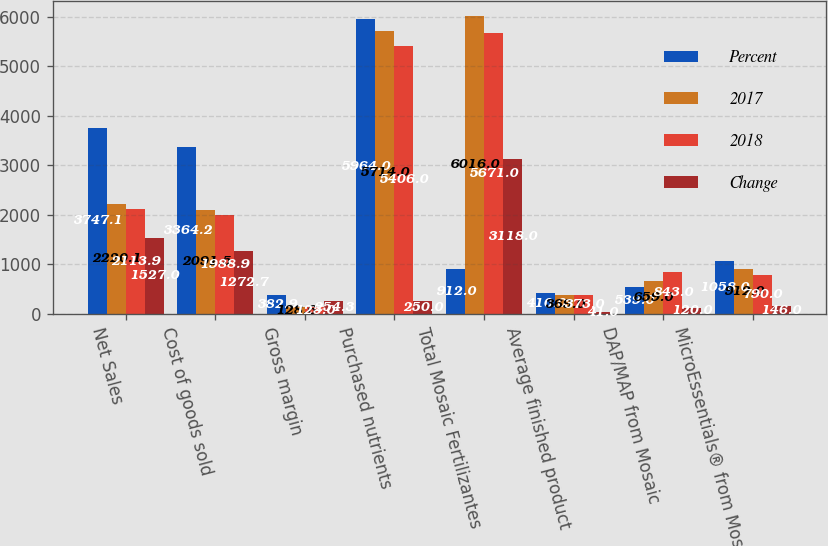Convert chart. <chart><loc_0><loc_0><loc_500><loc_500><stacked_bar_chart><ecel><fcel>Net Sales<fcel>Cost of goods sold<fcel>Gross margin<fcel>Purchased nutrients<fcel>Total Mosaic Fertilizantes<fcel>Average finished product<fcel>DAP/MAP from Mosaic<fcel>MicroEssentials® from Mosaic<nl><fcel>Percent<fcel>3747.1<fcel>3364.2<fcel>382.9<fcel>5964<fcel>912<fcel>410<fcel>539<fcel>1058<nl><fcel>2017<fcel>2220.1<fcel>2091.5<fcel>128.6<fcel>5714<fcel>6016<fcel>369<fcel>659<fcel>912<nl><fcel>2018<fcel>2113.9<fcel>1988.9<fcel>125<fcel>5406<fcel>5671<fcel>373<fcel>843<fcel>790<nl><fcel>Change<fcel>1527<fcel>1272.7<fcel>254.3<fcel>250<fcel>3118<fcel>41<fcel>120<fcel>146<nl></chart> 